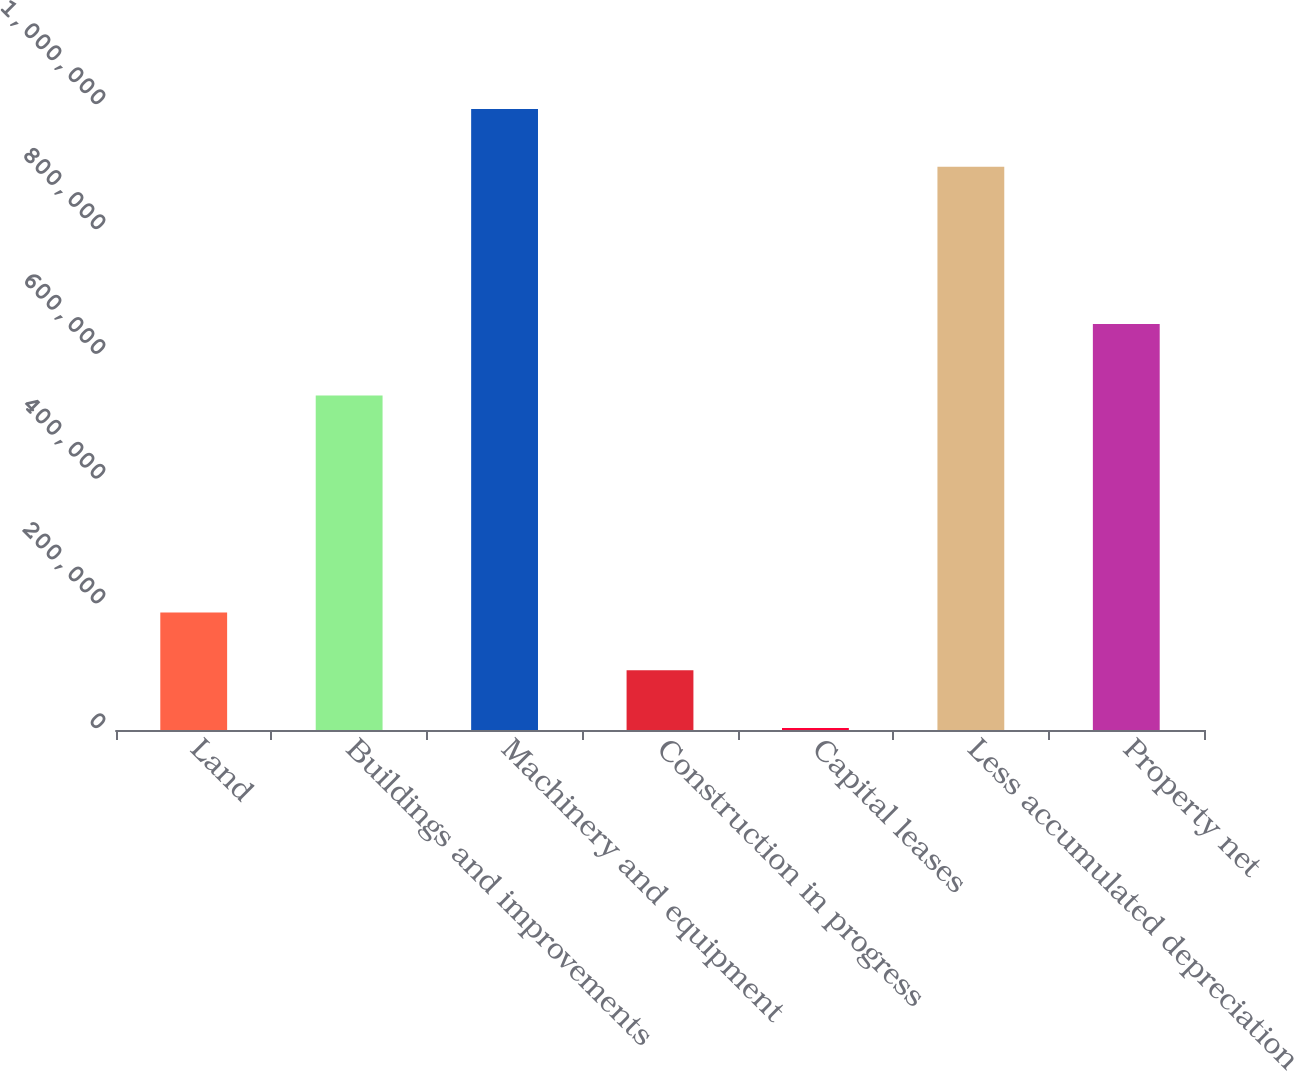Convert chart. <chart><loc_0><loc_0><loc_500><loc_500><bar_chart><fcel>Land<fcel>Buildings and improvements<fcel>Machinery and equipment<fcel>Construction in progress<fcel>Capital leases<fcel>Less accumulated depreciation<fcel>Property net<nl><fcel>188164<fcel>535898<fcel>995138<fcel>95684.4<fcel>3205<fcel>902659<fcel>650462<nl></chart> 